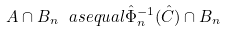Convert formula to latex. <formula><loc_0><loc_0><loc_500><loc_500>A \cap B _ { n } \ a s e q u a l \hat { \Phi } _ { n } ^ { - 1 } ( \hat { C } ) \cap B _ { n }</formula> 